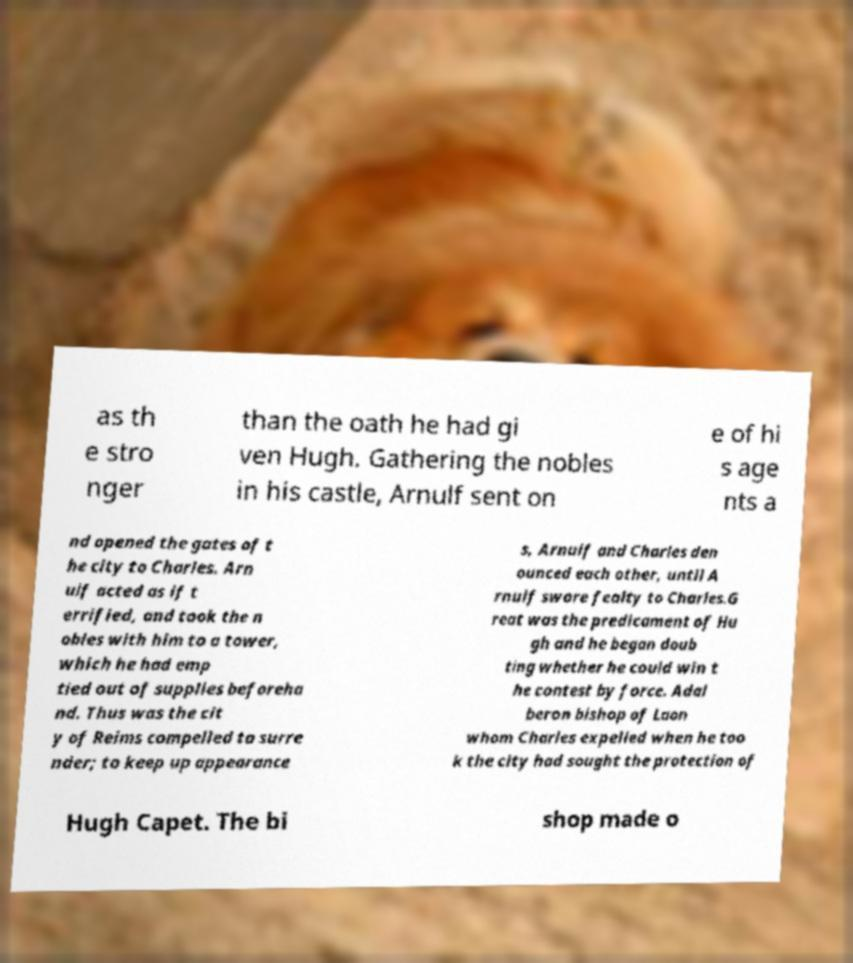I need the written content from this picture converted into text. Can you do that? as th e stro nger than the oath he had gi ven Hugh. Gathering the nobles in his castle, Arnulf sent on e of hi s age nts a nd opened the gates of t he city to Charles. Arn ulf acted as if t errified, and took the n obles with him to a tower, which he had emp tied out of supplies beforeha nd. Thus was the cit y of Reims compelled to surre nder; to keep up appearance s, Arnulf and Charles den ounced each other, until A rnulf swore fealty to Charles.G reat was the predicament of Hu gh and he began doub ting whether he could win t he contest by force. Adal beron bishop of Laon whom Charles expelled when he too k the city had sought the protection of Hugh Capet. The bi shop made o 